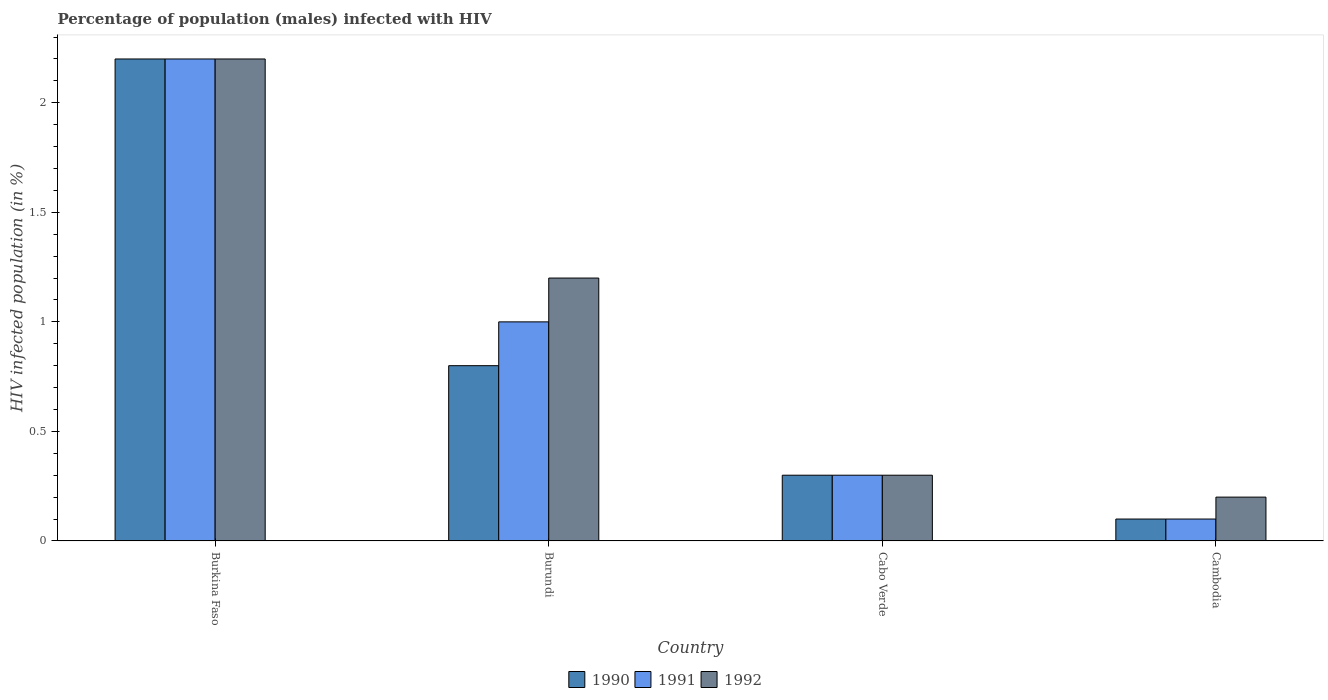How many different coloured bars are there?
Provide a succinct answer. 3. How many groups of bars are there?
Provide a short and direct response. 4. How many bars are there on the 2nd tick from the left?
Provide a short and direct response. 3. What is the label of the 4th group of bars from the left?
Keep it short and to the point. Cambodia. Across all countries, what is the maximum percentage of HIV infected male population in 1990?
Your response must be concise. 2.2. Across all countries, what is the minimum percentage of HIV infected male population in 1991?
Provide a succinct answer. 0.1. In which country was the percentage of HIV infected male population in 1991 maximum?
Ensure brevity in your answer.  Burkina Faso. In which country was the percentage of HIV infected male population in 1991 minimum?
Your answer should be very brief. Cambodia. What is the total percentage of HIV infected male population in 1992 in the graph?
Provide a short and direct response. 3.9. What is the difference between the percentage of HIV infected male population in 1990 in Burkina Faso and that in Cambodia?
Your answer should be compact. 2.1. What is the average percentage of HIV infected male population in 1991 per country?
Your answer should be compact. 0.9. What is the difference between the percentage of HIV infected male population of/in 1990 and percentage of HIV infected male population of/in 1992 in Cambodia?
Provide a short and direct response. -0.1. What is the ratio of the percentage of HIV infected male population in 1990 in Burkina Faso to that in Burundi?
Provide a succinct answer. 2.75. Is the percentage of HIV infected male population in 1992 in Burkina Faso less than that in Cabo Verde?
Provide a short and direct response. No. What is the difference between the highest and the second highest percentage of HIV infected male population in 1992?
Offer a terse response. -0.9. What is the difference between the highest and the lowest percentage of HIV infected male population in 1991?
Provide a short and direct response. 2.1. Is the sum of the percentage of HIV infected male population in 1992 in Burundi and Cabo Verde greater than the maximum percentage of HIV infected male population in 1990 across all countries?
Offer a terse response. No. What does the 2nd bar from the right in Burundi represents?
Provide a short and direct response. 1991. How many bars are there?
Your answer should be very brief. 12. How many countries are there in the graph?
Your answer should be compact. 4. Does the graph contain any zero values?
Give a very brief answer. No. Where does the legend appear in the graph?
Ensure brevity in your answer.  Bottom center. How many legend labels are there?
Offer a terse response. 3. What is the title of the graph?
Provide a succinct answer. Percentage of population (males) infected with HIV. Does "2006" appear as one of the legend labels in the graph?
Give a very brief answer. No. What is the label or title of the Y-axis?
Keep it short and to the point. HIV infected population (in %). What is the HIV infected population (in %) in 1991 in Burundi?
Your answer should be very brief. 1. What is the HIV infected population (in %) in 1990 in Cabo Verde?
Keep it short and to the point. 0.3. What is the HIV infected population (in %) in 1991 in Cabo Verde?
Offer a terse response. 0.3. What is the HIV infected population (in %) in 1991 in Cambodia?
Keep it short and to the point. 0.1. Across all countries, what is the maximum HIV infected population (in %) of 1991?
Give a very brief answer. 2.2. Across all countries, what is the maximum HIV infected population (in %) of 1992?
Offer a very short reply. 2.2. What is the total HIV infected population (in %) of 1990 in the graph?
Ensure brevity in your answer.  3.4. What is the total HIV infected population (in %) in 1992 in the graph?
Make the answer very short. 3.9. What is the difference between the HIV infected population (in %) of 1991 in Burkina Faso and that in Burundi?
Your answer should be very brief. 1.2. What is the difference between the HIV infected population (in %) in 1990 in Burkina Faso and that in Cabo Verde?
Make the answer very short. 1.9. What is the difference between the HIV infected population (in %) of 1992 in Burkina Faso and that in Cabo Verde?
Your answer should be very brief. 1.9. What is the difference between the HIV infected population (in %) in 1990 in Burundi and that in Cabo Verde?
Make the answer very short. 0.5. What is the difference between the HIV infected population (in %) of 1990 in Burundi and that in Cambodia?
Keep it short and to the point. 0.7. What is the difference between the HIV infected population (in %) of 1990 in Cabo Verde and that in Cambodia?
Give a very brief answer. 0.2. What is the difference between the HIV infected population (in %) of 1990 in Burkina Faso and the HIV infected population (in %) of 1991 in Burundi?
Offer a very short reply. 1.2. What is the difference between the HIV infected population (in %) in 1991 in Burkina Faso and the HIV infected population (in %) in 1992 in Burundi?
Offer a terse response. 1. What is the difference between the HIV infected population (in %) in 1990 in Burkina Faso and the HIV infected population (in %) in 1991 in Cabo Verde?
Ensure brevity in your answer.  1.9. What is the difference between the HIV infected population (in %) of 1990 in Burkina Faso and the HIV infected population (in %) of 1992 in Cabo Verde?
Offer a terse response. 1.9. What is the difference between the HIV infected population (in %) of 1990 in Burkina Faso and the HIV infected population (in %) of 1991 in Cambodia?
Your answer should be compact. 2.1. What is the difference between the HIV infected population (in %) in 1991 in Burkina Faso and the HIV infected population (in %) in 1992 in Cambodia?
Your answer should be compact. 2. What is the difference between the HIV infected population (in %) of 1990 in Burundi and the HIV infected population (in %) of 1991 in Cabo Verde?
Make the answer very short. 0.5. What is the difference between the HIV infected population (in %) in 1990 in Burundi and the HIV infected population (in %) in 1992 in Cabo Verde?
Make the answer very short. 0.5. What is the difference between the HIV infected population (in %) in 1991 in Burundi and the HIV infected population (in %) in 1992 in Cabo Verde?
Offer a very short reply. 0.7. What is the difference between the HIV infected population (in %) of 1990 in Burundi and the HIV infected population (in %) of 1992 in Cambodia?
Provide a short and direct response. 0.6. What is the difference between the HIV infected population (in %) of 1990 in Cabo Verde and the HIV infected population (in %) of 1992 in Cambodia?
Offer a terse response. 0.1. What is the difference between the HIV infected population (in %) in 1990 and HIV infected population (in %) in 1992 in Burkina Faso?
Your answer should be compact. 0. What is the difference between the HIV infected population (in %) of 1991 and HIV infected population (in %) of 1992 in Burkina Faso?
Keep it short and to the point. 0. What is the difference between the HIV infected population (in %) of 1990 and HIV infected population (in %) of 1992 in Burundi?
Provide a succinct answer. -0.4. What is the difference between the HIV infected population (in %) of 1990 and HIV infected population (in %) of 1992 in Cabo Verde?
Your response must be concise. 0. What is the difference between the HIV infected population (in %) of 1991 and HIV infected population (in %) of 1992 in Cabo Verde?
Provide a succinct answer. 0. What is the difference between the HIV infected population (in %) in 1990 and HIV infected population (in %) in 1991 in Cambodia?
Give a very brief answer. 0. What is the difference between the HIV infected population (in %) in 1991 and HIV infected population (in %) in 1992 in Cambodia?
Make the answer very short. -0.1. What is the ratio of the HIV infected population (in %) in 1990 in Burkina Faso to that in Burundi?
Your answer should be compact. 2.75. What is the ratio of the HIV infected population (in %) of 1992 in Burkina Faso to that in Burundi?
Your response must be concise. 1.83. What is the ratio of the HIV infected population (in %) of 1990 in Burkina Faso to that in Cabo Verde?
Your answer should be compact. 7.33. What is the ratio of the HIV infected population (in %) in 1991 in Burkina Faso to that in Cabo Verde?
Your answer should be very brief. 7.33. What is the ratio of the HIV infected population (in %) of 1992 in Burkina Faso to that in Cabo Verde?
Your answer should be compact. 7.33. What is the ratio of the HIV infected population (in %) of 1990 in Burkina Faso to that in Cambodia?
Give a very brief answer. 22. What is the ratio of the HIV infected population (in %) of 1991 in Burkina Faso to that in Cambodia?
Offer a very short reply. 22. What is the ratio of the HIV infected population (in %) in 1992 in Burkina Faso to that in Cambodia?
Provide a short and direct response. 11. What is the ratio of the HIV infected population (in %) of 1990 in Burundi to that in Cabo Verde?
Make the answer very short. 2.67. What is the ratio of the HIV infected population (in %) in 1991 in Burundi to that in Cabo Verde?
Offer a very short reply. 3.33. What is the ratio of the HIV infected population (in %) in 1991 in Burundi to that in Cambodia?
Keep it short and to the point. 10. What is the ratio of the HIV infected population (in %) in 1992 in Burundi to that in Cambodia?
Make the answer very short. 6. What is the ratio of the HIV infected population (in %) of 1990 in Cabo Verde to that in Cambodia?
Your answer should be compact. 3. What is the ratio of the HIV infected population (in %) of 1991 in Cabo Verde to that in Cambodia?
Your answer should be very brief. 3. What is the difference between the highest and the second highest HIV infected population (in %) of 1990?
Offer a very short reply. 1.4. What is the difference between the highest and the second highest HIV infected population (in %) of 1991?
Keep it short and to the point. 1.2. What is the difference between the highest and the lowest HIV infected population (in %) of 1990?
Provide a short and direct response. 2.1. What is the difference between the highest and the lowest HIV infected population (in %) in 1992?
Make the answer very short. 2. 